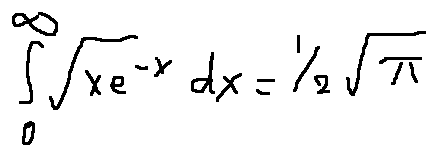Convert formula to latex. <formula><loc_0><loc_0><loc_500><loc_500>\int \lim i t s _ { 0 } ^ { \infty } \sqrt { x } e ^ { - x } d x = \frac { 1 } { 2 } \sqrt { \pi }</formula> 